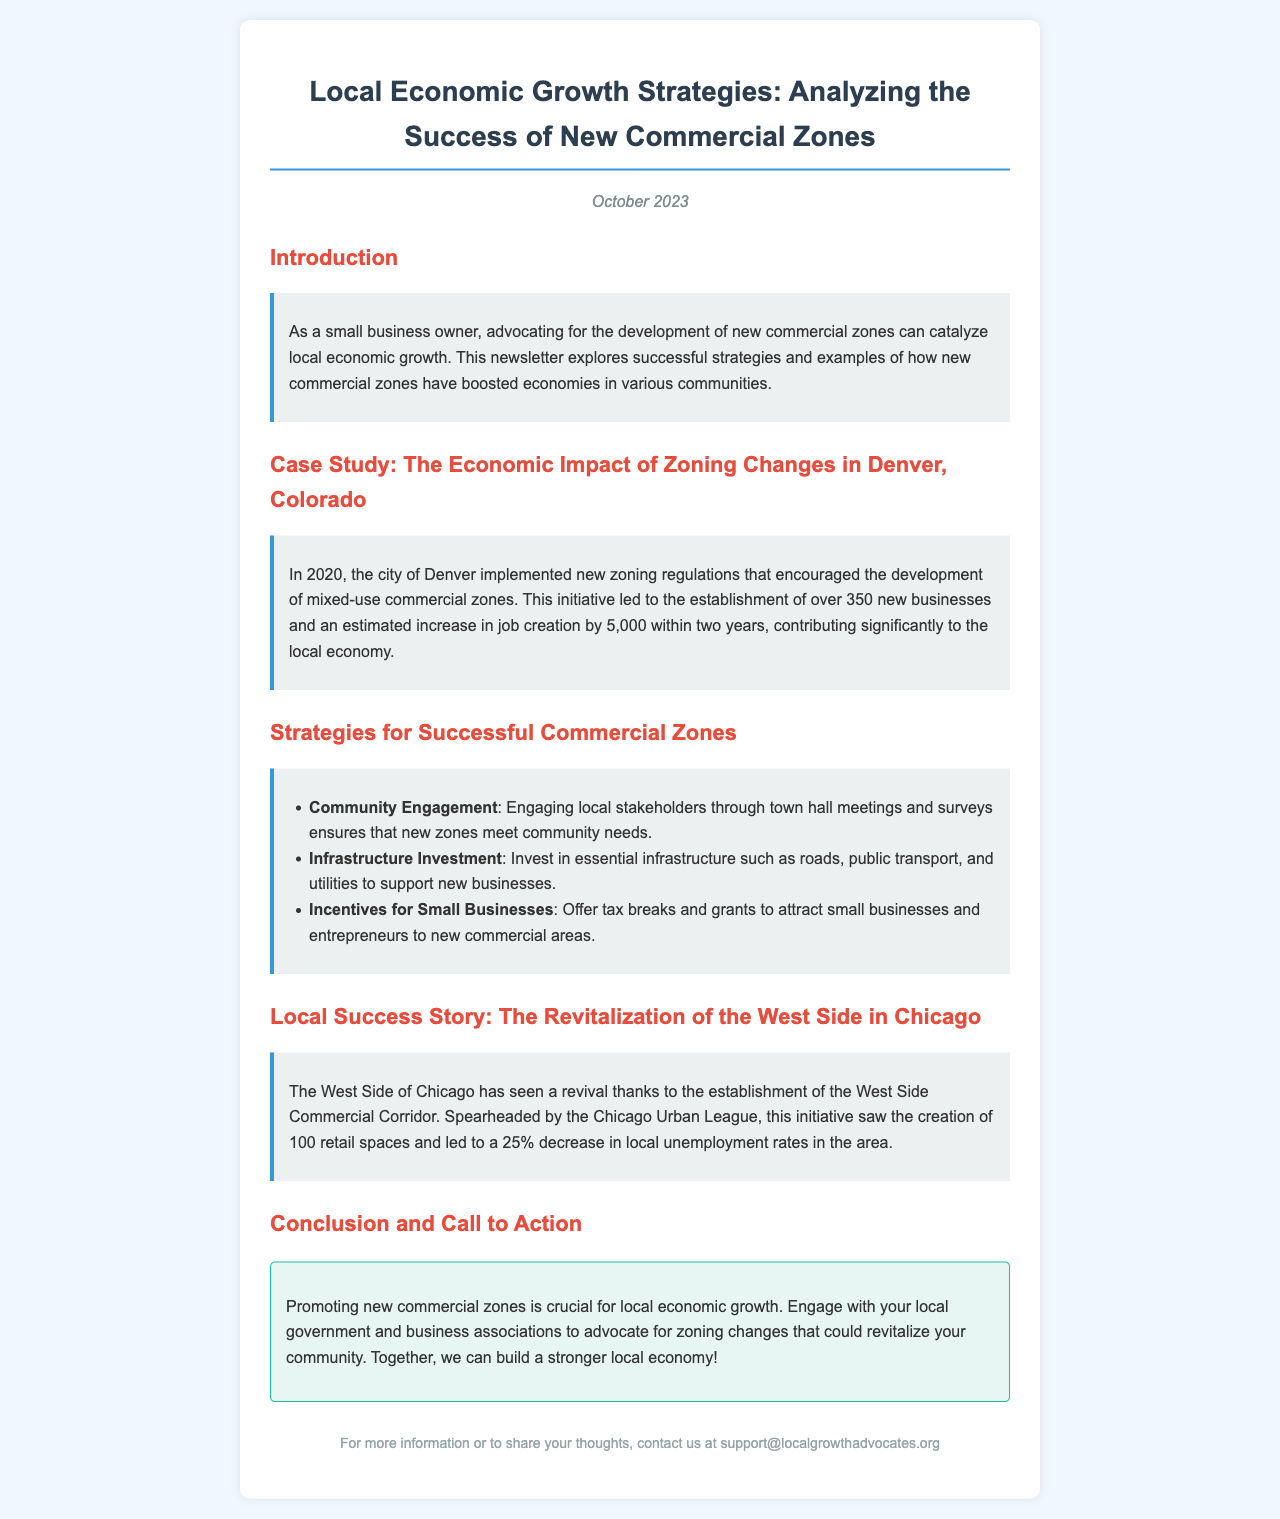What is the main topic of the newsletter? The newsletter focuses on strategies for boosting local economic growth through new commercial zones.
Answer: Local Economic Growth Strategies What city was used as a case study in the newsletter? The case study highlighted zoning changes in a specific city that had positive economic impacts.
Answer: Denver, Colorado How many new businesses were established in Denver due to the zoning changes? The text specifies the number of new businesses established in Denver as a result of the zoning initiative.
Answer: 350 What is one strategy mentioned for successful commercial zones? The newsletter lists strategies for developing successful commercial zones, including specific stakeholder engagement.
Answer: Community Engagement What percentage decrease in local unemployment rates occurred in the West Side of Chicago? The newsletter provides specific data on unemployment rates following revitalization efforts in a specific area.
Answer: 25% What year did Denver implement the new zoning regulations? The document mentions the year when the new zoning regulations were initiated in Denver.
Answer: 2020 What organization spearheaded the West Side Commercial Corridor initiative? The newsletter identifies an organization that played a crucial role in developing the West Side Commercial Corridor.
Answer: Chicago Urban League What is the call to action in the conclusion? The conclusion urges a specific action that local business owners should take regarding economic growth.
Answer: Advocate for zoning changes 